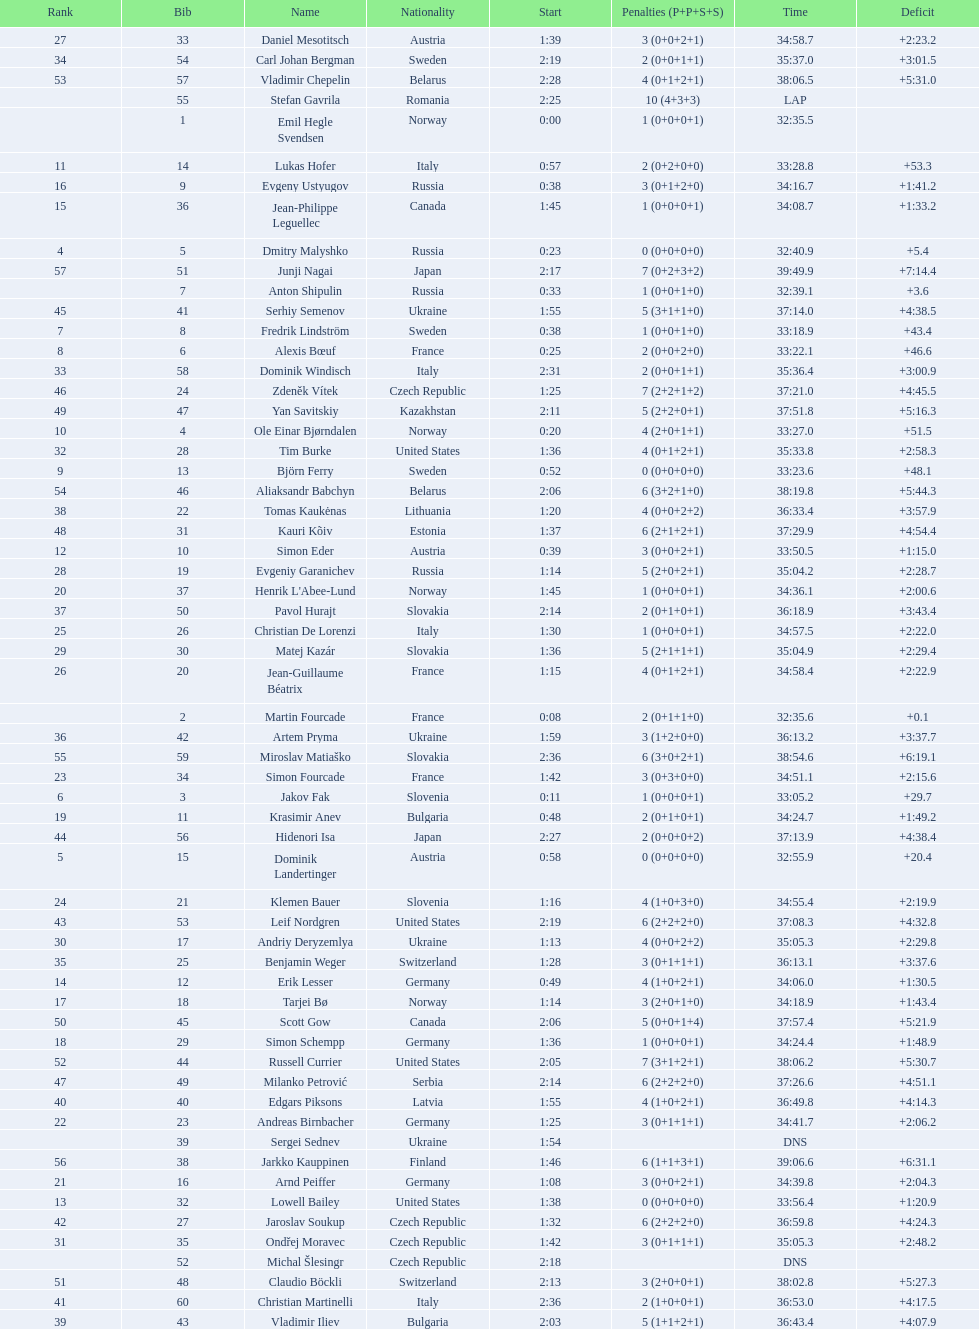Other than burke, name an athlete from the us. Leif Nordgren. 